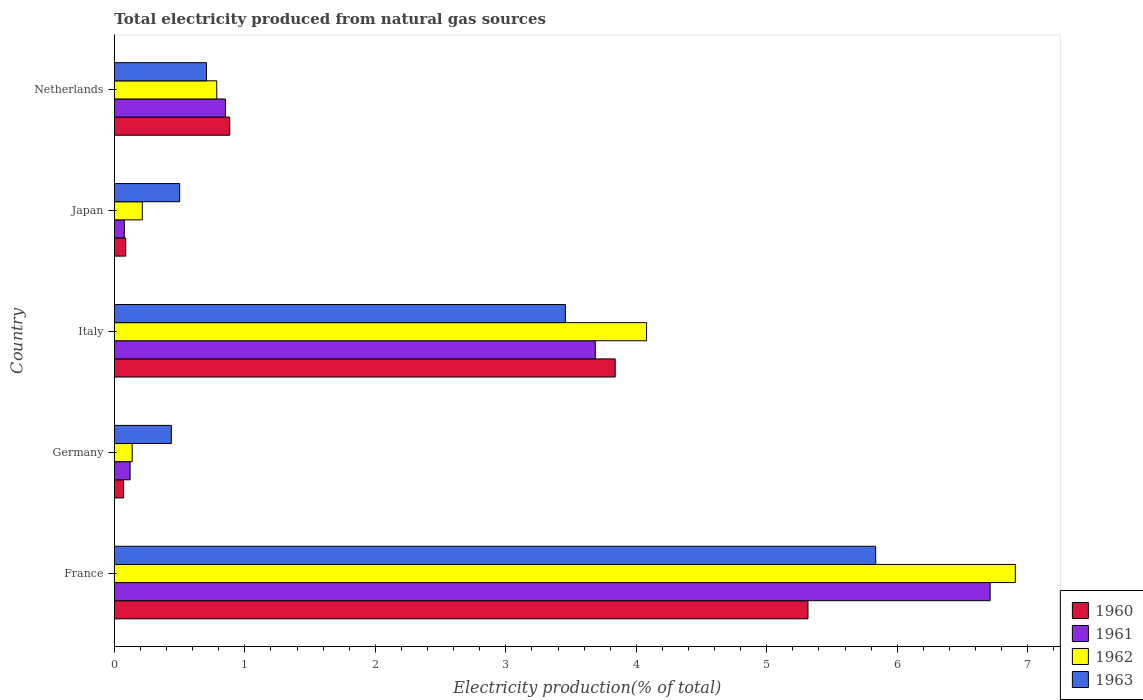Are the number of bars per tick equal to the number of legend labels?
Offer a terse response. Yes. Are the number of bars on each tick of the Y-axis equal?
Provide a short and direct response. Yes. What is the label of the 4th group of bars from the top?
Keep it short and to the point. Germany. What is the total electricity produced in 1963 in Italy?
Keep it short and to the point. 3.46. Across all countries, what is the maximum total electricity produced in 1960?
Offer a terse response. 5.32. Across all countries, what is the minimum total electricity produced in 1961?
Give a very brief answer. 0.08. In which country was the total electricity produced in 1961 maximum?
Make the answer very short. France. In which country was the total electricity produced in 1963 minimum?
Keep it short and to the point. Germany. What is the total total electricity produced in 1962 in the graph?
Your answer should be very brief. 12.12. What is the difference between the total electricity produced in 1963 in France and that in Netherlands?
Provide a succinct answer. 5.13. What is the difference between the total electricity produced in 1960 in Germany and the total electricity produced in 1963 in Netherlands?
Your answer should be compact. -0.64. What is the average total electricity produced in 1963 per country?
Keep it short and to the point. 2.19. What is the difference between the total electricity produced in 1963 and total electricity produced in 1961 in France?
Offer a very short reply. -0.88. What is the ratio of the total electricity produced in 1962 in Italy to that in Japan?
Offer a terse response. 19.09. Is the difference between the total electricity produced in 1963 in Germany and Netherlands greater than the difference between the total electricity produced in 1961 in Germany and Netherlands?
Your response must be concise. Yes. What is the difference between the highest and the second highest total electricity produced in 1960?
Make the answer very short. 1.48. What is the difference between the highest and the lowest total electricity produced in 1962?
Provide a short and direct response. 6.77. Is the sum of the total electricity produced in 1961 in Japan and Netherlands greater than the maximum total electricity produced in 1962 across all countries?
Ensure brevity in your answer.  No. What does the 2nd bar from the top in Netherlands represents?
Provide a short and direct response. 1962. Is it the case that in every country, the sum of the total electricity produced in 1960 and total electricity produced in 1963 is greater than the total electricity produced in 1961?
Ensure brevity in your answer.  Yes. How many bars are there?
Your response must be concise. 20. Are all the bars in the graph horizontal?
Provide a succinct answer. Yes. What is the difference between two consecutive major ticks on the X-axis?
Offer a terse response. 1. Where does the legend appear in the graph?
Provide a short and direct response. Bottom right. How are the legend labels stacked?
Provide a succinct answer. Vertical. What is the title of the graph?
Provide a short and direct response. Total electricity produced from natural gas sources. Does "1978" appear as one of the legend labels in the graph?
Provide a succinct answer. No. What is the label or title of the X-axis?
Keep it short and to the point. Electricity production(% of total). What is the label or title of the Y-axis?
Provide a short and direct response. Country. What is the Electricity production(% of total) in 1960 in France?
Your response must be concise. 5.32. What is the Electricity production(% of total) in 1961 in France?
Make the answer very short. 6.71. What is the Electricity production(% of total) of 1962 in France?
Provide a succinct answer. 6.91. What is the Electricity production(% of total) of 1963 in France?
Ensure brevity in your answer.  5.83. What is the Electricity production(% of total) in 1960 in Germany?
Offer a terse response. 0.07. What is the Electricity production(% of total) in 1961 in Germany?
Provide a short and direct response. 0.12. What is the Electricity production(% of total) in 1962 in Germany?
Your answer should be very brief. 0.14. What is the Electricity production(% of total) in 1963 in Germany?
Give a very brief answer. 0.44. What is the Electricity production(% of total) in 1960 in Italy?
Your answer should be compact. 3.84. What is the Electricity production(% of total) of 1961 in Italy?
Your answer should be compact. 3.69. What is the Electricity production(% of total) in 1962 in Italy?
Make the answer very short. 4.08. What is the Electricity production(% of total) of 1963 in Italy?
Ensure brevity in your answer.  3.46. What is the Electricity production(% of total) of 1960 in Japan?
Offer a terse response. 0.09. What is the Electricity production(% of total) of 1961 in Japan?
Keep it short and to the point. 0.08. What is the Electricity production(% of total) in 1962 in Japan?
Ensure brevity in your answer.  0.21. What is the Electricity production(% of total) in 1963 in Japan?
Offer a terse response. 0.5. What is the Electricity production(% of total) of 1960 in Netherlands?
Provide a short and direct response. 0.88. What is the Electricity production(% of total) of 1961 in Netherlands?
Ensure brevity in your answer.  0.85. What is the Electricity production(% of total) in 1962 in Netherlands?
Offer a terse response. 0.78. What is the Electricity production(% of total) of 1963 in Netherlands?
Ensure brevity in your answer.  0.71. Across all countries, what is the maximum Electricity production(% of total) in 1960?
Ensure brevity in your answer.  5.32. Across all countries, what is the maximum Electricity production(% of total) in 1961?
Your answer should be compact. 6.71. Across all countries, what is the maximum Electricity production(% of total) in 1962?
Ensure brevity in your answer.  6.91. Across all countries, what is the maximum Electricity production(% of total) of 1963?
Your answer should be compact. 5.83. Across all countries, what is the minimum Electricity production(% of total) in 1960?
Make the answer very short. 0.07. Across all countries, what is the minimum Electricity production(% of total) of 1961?
Provide a succinct answer. 0.08. Across all countries, what is the minimum Electricity production(% of total) of 1962?
Provide a short and direct response. 0.14. Across all countries, what is the minimum Electricity production(% of total) of 1963?
Provide a short and direct response. 0.44. What is the total Electricity production(% of total) in 1960 in the graph?
Provide a succinct answer. 10.19. What is the total Electricity production(% of total) of 1961 in the graph?
Your response must be concise. 11.45. What is the total Electricity production(% of total) in 1962 in the graph?
Offer a terse response. 12.12. What is the total Electricity production(% of total) in 1963 in the graph?
Keep it short and to the point. 10.93. What is the difference between the Electricity production(% of total) in 1960 in France and that in Germany?
Your answer should be very brief. 5.25. What is the difference between the Electricity production(% of total) in 1961 in France and that in Germany?
Give a very brief answer. 6.59. What is the difference between the Electricity production(% of total) in 1962 in France and that in Germany?
Your response must be concise. 6.77. What is the difference between the Electricity production(% of total) in 1963 in France and that in Germany?
Ensure brevity in your answer.  5.4. What is the difference between the Electricity production(% of total) in 1960 in France and that in Italy?
Provide a short and direct response. 1.48. What is the difference between the Electricity production(% of total) of 1961 in France and that in Italy?
Provide a short and direct response. 3.03. What is the difference between the Electricity production(% of total) in 1962 in France and that in Italy?
Your answer should be compact. 2.83. What is the difference between the Electricity production(% of total) of 1963 in France and that in Italy?
Offer a very short reply. 2.38. What is the difference between the Electricity production(% of total) in 1960 in France and that in Japan?
Your response must be concise. 5.23. What is the difference between the Electricity production(% of total) of 1961 in France and that in Japan?
Provide a short and direct response. 6.64. What is the difference between the Electricity production(% of total) of 1962 in France and that in Japan?
Your answer should be compact. 6.69. What is the difference between the Electricity production(% of total) in 1963 in France and that in Japan?
Your answer should be compact. 5.33. What is the difference between the Electricity production(% of total) in 1960 in France and that in Netherlands?
Give a very brief answer. 4.43. What is the difference between the Electricity production(% of total) in 1961 in France and that in Netherlands?
Provide a short and direct response. 5.86. What is the difference between the Electricity production(% of total) in 1962 in France and that in Netherlands?
Provide a short and direct response. 6.12. What is the difference between the Electricity production(% of total) of 1963 in France and that in Netherlands?
Provide a succinct answer. 5.13. What is the difference between the Electricity production(% of total) in 1960 in Germany and that in Italy?
Offer a very short reply. -3.77. What is the difference between the Electricity production(% of total) in 1961 in Germany and that in Italy?
Make the answer very short. -3.57. What is the difference between the Electricity production(% of total) in 1962 in Germany and that in Italy?
Provide a short and direct response. -3.94. What is the difference between the Electricity production(% of total) of 1963 in Germany and that in Italy?
Your answer should be compact. -3.02. What is the difference between the Electricity production(% of total) of 1960 in Germany and that in Japan?
Your response must be concise. -0.02. What is the difference between the Electricity production(% of total) of 1961 in Germany and that in Japan?
Offer a very short reply. 0.04. What is the difference between the Electricity production(% of total) in 1962 in Germany and that in Japan?
Offer a terse response. -0.08. What is the difference between the Electricity production(% of total) in 1963 in Germany and that in Japan?
Provide a short and direct response. -0.06. What is the difference between the Electricity production(% of total) of 1960 in Germany and that in Netherlands?
Give a very brief answer. -0.81. What is the difference between the Electricity production(% of total) in 1961 in Germany and that in Netherlands?
Offer a very short reply. -0.73. What is the difference between the Electricity production(% of total) of 1962 in Germany and that in Netherlands?
Your response must be concise. -0.65. What is the difference between the Electricity production(% of total) of 1963 in Germany and that in Netherlands?
Provide a short and direct response. -0.27. What is the difference between the Electricity production(% of total) of 1960 in Italy and that in Japan?
Provide a short and direct response. 3.75. What is the difference between the Electricity production(% of total) in 1961 in Italy and that in Japan?
Make the answer very short. 3.61. What is the difference between the Electricity production(% of total) of 1962 in Italy and that in Japan?
Offer a very short reply. 3.86. What is the difference between the Electricity production(% of total) in 1963 in Italy and that in Japan?
Your response must be concise. 2.96. What is the difference between the Electricity production(% of total) of 1960 in Italy and that in Netherlands?
Your answer should be compact. 2.95. What is the difference between the Electricity production(% of total) of 1961 in Italy and that in Netherlands?
Give a very brief answer. 2.83. What is the difference between the Electricity production(% of total) in 1962 in Italy and that in Netherlands?
Provide a succinct answer. 3.29. What is the difference between the Electricity production(% of total) in 1963 in Italy and that in Netherlands?
Make the answer very short. 2.75. What is the difference between the Electricity production(% of total) in 1960 in Japan and that in Netherlands?
Keep it short and to the point. -0.8. What is the difference between the Electricity production(% of total) in 1961 in Japan and that in Netherlands?
Your answer should be very brief. -0.78. What is the difference between the Electricity production(% of total) in 1962 in Japan and that in Netherlands?
Keep it short and to the point. -0.57. What is the difference between the Electricity production(% of total) in 1963 in Japan and that in Netherlands?
Ensure brevity in your answer.  -0.21. What is the difference between the Electricity production(% of total) of 1960 in France and the Electricity production(% of total) of 1961 in Germany?
Provide a short and direct response. 5.2. What is the difference between the Electricity production(% of total) of 1960 in France and the Electricity production(% of total) of 1962 in Germany?
Provide a short and direct response. 5.18. What is the difference between the Electricity production(% of total) in 1960 in France and the Electricity production(% of total) in 1963 in Germany?
Your answer should be compact. 4.88. What is the difference between the Electricity production(% of total) in 1961 in France and the Electricity production(% of total) in 1962 in Germany?
Your answer should be compact. 6.58. What is the difference between the Electricity production(% of total) of 1961 in France and the Electricity production(% of total) of 1963 in Germany?
Provide a short and direct response. 6.28. What is the difference between the Electricity production(% of total) in 1962 in France and the Electricity production(% of total) in 1963 in Germany?
Give a very brief answer. 6.47. What is the difference between the Electricity production(% of total) of 1960 in France and the Electricity production(% of total) of 1961 in Italy?
Make the answer very short. 1.63. What is the difference between the Electricity production(% of total) of 1960 in France and the Electricity production(% of total) of 1962 in Italy?
Provide a succinct answer. 1.24. What is the difference between the Electricity production(% of total) of 1960 in France and the Electricity production(% of total) of 1963 in Italy?
Make the answer very short. 1.86. What is the difference between the Electricity production(% of total) in 1961 in France and the Electricity production(% of total) in 1962 in Italy?
Offer a very short reply. 2.63. What is the difference between the Electricity production(% of total) in 1961 in France and the Electricity production(% of total) in 1963 in Italy?
Make the answer very short. 3.26. What is the difference between the Electricity production(% of total) in 1962 in France and the Electricity production(% of total) in 1963 in Italy?
Offer a very short reply. 3.45. What is the difference between the Electricity production(% of total) of 1960 in France and the Electricity production(% of total) of 1961 in Japan?
Offer a very short reply. 5.24. What is the difference between the Electricity production(% of total) of 1960 in France and the Electricity production(% of total) of 1962 in Japan?
Ensure brevity in your answer.  5.1. What is the difference between the Electricity production(% of total) in 1960 in France and the Electricity production(% of total) in 1963 in Japan?
Offer a terse response. 4.82. What is the difference between the Electricity production(% of total) of 1961 in France and the Electricity production(% of total) of 1962 in Japan?
Provide a succinct answer. 6.5. What is the difference between the Electricity production(% of total) in 1961 in France and the Electricity production(% of total) in 1963 in Japan?
Provide a succinct answer. 6.21. What is the difference between the Electricity production(% of total) of 1962 in France and the Electricity production(% of total) of 1963 in Japan?
Your response must be concise. 6.4. What is the difference between the Electricity production(% of total) in 1960 in France and the Electricity production(% of total) in 1961 in Netherlands?
Offer a very short reply. 4.46. What is the difference between the Electricity production(% of total) in 1960 in France and the Electricity production(% of total) in 1962 in Netherlands?
Your response must be concise. 4.53. What is the difference between the Electricity production(% of total) of 1960 in France and the Electricity production(% of total) of 1963 in Netherlands?
Keep it short and to the point. 4.61. What is the difference between the Electricity production(% of total) of 1961 in France and the Electricity production(% of total) of 1962 in Netherlands?
Give a very brief answer. 5.93. What is the difference between the Electricity production(% of total) of 1961 in France and the Electricity production(% of total) of 1963 in Netherlands?
Make the answer very short. 6.01. What is the difference between the Electricity production(% of total) in 1962 in France and the Electricity production(% of total) in 1963 in Netherlands?
Your response must be concise. 6.2. What is the difference between the Electricity production(% of total) of 1960 in Germany and the Electricity production(% of total) of 1961 in Italy?
Provide a short and direct response. -3.62. What is the difference between the Electricity production(% of total) of 1960 in Germany and the Electricity production(% of total) of 1962 in Italy?
Provide a short and direct response. -4.01. What is the difference between the Electricity production(% of total) of 1960 in Germany and the Electricity production(% of total) of 1963 in Italy?
Offer a very short reply. -3.39. What is the difference between the Electricity production(% of total) in 1961 in Germany and the Electricity production(% of total) in 1962 in Italy?
Your answer should be compact. -3.96. What is the difference between the Electricity production(% of total) in 1961 in Germany and the Electricity production(% of total) in 1963 in Italy?
Keep it short and to the point. -3.34. What is the difference between the Electricity production(% of total) in 1962 in Germany and the Electricity production(% of total) in 1963 in Italy?
Provide a succinct answer. -3.32. What is the difference between the Electricity production(% of total) of 1960 in Germany and the Electricity production(% of total) of 1961 in Japan?
Provide a short and direct response. -0.01. What is the difference between the Electricity production(% of total) of 1960 in Germany and the Electricity production(% of total) of 1962 in Japan?
Offer a very short reply. -0.14. What is the difference between the Electricity production(% of total) of 1960 in Germany and the Electricity production(% of total) of 1963 in Japan?
Your answer should be very brief. -0.43. What is the difference between the Electricity production(% of total) of 1961 in Germany and the Electricity production(% of total) of 1962 in Japan?
Your answer should be compact. -0.09. What is the difference between the Electricity production(% of total) in 1961 in Germany and the Electricity production(% of total) in 1963 in Japan?
Make the answer very short. -0.38. What is the difference between the Electricity production(% of total) of 1962 in Germany and the Electricity production(% of total) of 1963 in Japan?
Provide a succinct answer. -0.36. What is the difference between the Electricity production(% of total) of 1960 in Germany and the Electricity production(% of total) of 1961 in Netherlands?
Provide a short and direct response. -0.78. What is the difference between the Electricity production(% of total) of 1960 in Germany and the Electricity production(% of total) of 1962 in Netherlands?
Make the answer very short. -0.71. What is the difference between the Electricity production(% of total) in 1960 in Germany and the Electricity production(% of total) in 1963 in Netherlands?
Your answer should be compact. -0.64. What is the difference between the Electricity production(% of total) in 1961 in Germany and the Electricity production(% of total) in 1962 in Netherlands?
Your response must be concise. -0.66. What is the difference between the Electricity production(% of total) in 1961 in Germany and the Electricity production(% of total) in 1963 in Netherlands?
Ensure brevity in your answer.  -0.58. What is the difference between the Electricity production(% of total) in 1962 in Germany and the Electricity production(% of total) in 1963 in Netherlands?
Your answer should be very brief. -0.57. What is the difference between the Electricity production(% of total) of 1960 in Italy and the Electricity production(% of total) of 1961 in Japan?
Ensure brevity in your answer.  3.76. What is the difference between the Electricity production(% of total) of 1960 in Italy and the Electricity production(% of total) of 1962 in Japan?
Your answer should be very brief. 3.62. What is the difference between the Electricity production(% of total) in 1960 in Italy and the Electricity production(% of total) in 1963 in Japan?
Offer a very short reply. 3.34. What is the difference between the Electricity production(% of total) of 1961 in Italy and the Electricity production(% of total) of 1962 in Japan?
Make the answer very short. 3.47. What is the difference between the Electricity production(% of total) of 1961 in Italy and the Electricity production(% of total) of 1963 in Japan?
Your answer should be compact. 3.19. What is the difference between the Electricity production(% of total) in 1962 in Italy and the Electricity production(% of total) in 1963 in Japan?
Provide a short and direct response. 3.58. What is the difference between the Electricity production(% of total) in 1960 in Italy and the Electricity production(% of total) in 1961 in Netherlands?
Provide a succinct answer. 2.99. What is the difference between the Electricity production(% of total) in 1960 in Italy and the Electricity production(% of total) in 1962 in Netherlands?
Your answer should be very brief. 3.05. What is the difference between the Electricity production(% of total) in 1960 in Italy and the Electricity production(% of total) in 1963 in Netherlands?
Give a very brief answer. 3.13. What is the difference between the Electricity production(% of total) in 1961 in Italy and the Electricity production(% of total) in 1962 in Netherlands?
Provide a succinct answer. 2.9. What is the difference between the Electricity production(% of total) of 1961 in Italy and the Electricity production(% of total) of 1963 in Netherlands?
Your response must be concise. 2.98. What is the difference between the Electricity production(% of total) of 1962 in Italy and the Electricity production(% of total) of 1963 in Netherlands?
Provide a short and direct response. 3.37. What is the difference between the Electricity production(% of total) in 1960 in Japan and the Electricity production(% of total) in 1961 in Netherlands?
Make the answer very short. -0.76. What is the difference between the Electricity production(% of total) in 1960 in Japan and the Electricity production(% of total) in 1962 in Netherlands?
Your response must be concise. -0.7. What is the difference between the Electricity production(% of total) in 1960 in Japan and the Electricity production(% of total) in 1963 in Netherlands?
Offer a very short reply. -0.62. What is the difference between the Electricity production(% of total) of 1961 in Japan and the Electricity production(% of total) of 1962 in Netherlands?
Your response must be concise. -0.71. What is the difference between the Electricity production(% of total) of 1961 in Japan and the Electricity production(% of total) of 1963 in Netherlands?
Provide a short and direct response. -0.63. What is the difference between the Electricity production(% of total) of 1962 in Japan and the Electricity production(% of total) of 1963 in Netherlands?
Your answer should be compact. -0.49. What is the average Electricity production(% of total) of 1960 per country?
Keep it short and to the point. 2.04. What is the average Electricity production(% of total) in 1961 per country?
Offer a terse response. 2.29. What is the average Electricity production(% of total) of 1962 per country?
Your answer should be very brief. 2.42. What is the average Electricity production(% of total) of 1963 per country?
Offer a terse response. 2.19. What is the difference between the Electricity production(% of total) in 1960 and Electricity production(% of total) in 1961 in France?
Offer a terse response. -1.4. What is the difference between the Electricity production(% of total) in 1960 and Electricity production(% of total) in 1962 in France?
Provide a succinct answer. -1.59. What is the difference between the Electricity production(% of total) of 1960 and Electricity production(% of total) of 1963 in France?
Provide a short and direct response. -0.52. What is the difference between the Electricity production(% of total) of 1961 and Electricity production(% of total) of 1962 in France?
Make the answer very short. -0.19. What is the difference between the Electricity production(% of total) in 1961 and Electricity production(% of total) in 1963 in France?
Your answer should be very brief. 0.88. What is the difference between the Electricity production(% of total) in 1962 and Electricity production(% of total) in 1963 in France?
Provide a short and direct response. 1.07. What is the difference between the Electricity production(% of total) in 1960 and Electricity production(% of total) in 1962 in Germany?
Provide a short and direct response. -0.07. What is the difference between the Electricity production(% of total) of 1960 and Electricity production(% of total) of 1963 in Germany?
Ensure brevity in your answer.  -0.37. What is the difference between the Electricity production(% of total) in 1961 and Electricity production(% of total) in 1962 in Germany?
Your response must be concise. -0.02. What is the difference between the Electricity production(% of total) in 1961 and Electricity production(% of total) in 1963 in Germany?
Keep it short and to the point. -0.32. What is the difference between the Electricity production(% of total) in 1962 and Electricity production(% of total) in 1963 in Germany?
Keep it short and to the point. -0.3. What is the difference between the Electricity production(% of total) of 1960 and Electricity production(% of total) of 1961 in Italy?
Keep it short and to the point. 0.15. What is the difference between the Electricity production(% of total) of 1960 and Electricity production(% of total) of 1962 in Italy?
Ensure brevity in your answer.  -0.24. What is the difference between the Electricity production(% of total) of 1960 and Electricity production(% of total) of 1963 in Italy?
Provide a succinct answer. 0.38. What is the difference between the Electricity production(% of total) in 1961 and Electricity production(% of total) in 1962 in Italy?
Your answer should be very brief. -0.39. What is the difference between the Electricity production(% of total) of 1961 and Electricity production(% of total) of 1963 in Italy?
Your response must be concise. 0.23. What is the difference between the Electricity production(% of total) of 1962 and Electricity production(% of total) of 1963 in Italy?
Offer a very short reply. 0.62. What is the difference between the Electricity production(% of total) in 1960 and Electricity production(% of total) in 1961 in Japan?
Your response must be concise. 0.01. What is the difference between the Electricity production(% of total) in 1960 and Electricity production(% of total) in 1962 in Japan?
Keep it short and to the point. -0.13. What is the difference between the Electricity production(% of total) in 1960 and Electricity production(% of total) in 1963 in Japan?
Give a very brief answer. -0.41. What is the difference between the Electricity production(% of total) of 1961 and Electricity production(% of total) of 1962 in Japan?
Offer a very short reply. -0.14. What is the difference between the Electricity production(% of total) in 1961 and Electricity production(% of total) in 1963 in Japan?
Make the answer very short. -0.42. What is the difference between the Electricity production(% of total) of 1962 and Electricity production(% of total) of 1963 in Japan?
Your answer should be compact. -0.29. What is the difference between the Electricity production(% of total) of 1960 and Electricity production(% of total) of 1961 in Netherlands?
Provide a short and direct response. 0.03. What is the difference between the Electricity production(% of total) of 1960 and Electricity production(% of total) of 1962 in Netherlands?
Offer a very short reply. 0.1. What is the difference between the Electricity production(% of total) in 1960 and Electricity production(% of total) in 1963 in Netherlands?
Your response must be concise. 0.18. What is the difference between the Electricity production(% of total) in 1961 and Electricity production(% of total) in 1962 in Netherlands?
Make the answer very short. 0.07. What is the difference between the Electricity production(% of total) in 1961 and Electricity production(% of total) in 1963 in Netherlands?
Give a very brief answer. 0.15. What is the difference between the Electricity production(% of total) in 1962 and Electricity production(% of total) in 1963 in Netherlands?
Give a very brief answer. 0.08. What is the ratio of the Electricity production(% of total) in 1960 in France to that in Germany?
Give a very brief answer. 75.62. What is the ratio of the Electricity production(% of total) in 1961 in France to that in Germany?
Make the answer very short. 55.79. What is the ratio of the Electricity production(% of total) of 1962 in France to that in Germany?
Make the answer very short. 50.69. What is the ratio of the Electricity production(% of total) in 1963 in France to that in Germany?
Provide a short and direct response. 13.38. What is the ratio of the Electricity production(% of total) in 1960 in France to that in Italy?
Give a very brief answer. 1.39. What is the ratio of the Electricity production(% of total) of 1961 in France to that in Italy?
Your answer should be compact. 1.82. What is the ratio of the Electricity production(% of total) of 1962 in France to that in Italy?
Offer a terse response. 1.69. What is the ratio of the Electricity production(% of total) of 1963 in France to that in Italy?
Offer a terse response. 1.69. What is the ratio of the Electricity production(% of total) of 1960 in France to that in Japan?
Provide a succinct answer. 61.4. What is the ratio of the Electricity production(% of total) in 1961 in France to that in Japan?
Provide a short and direct response. 88.67. What is the ratio of the Electricity production(% of total) in 1962 in France to that in Japan?
Provide a short and direct response. 32.32. What is the ratio of the Electricity production(% of total) in 1963 in France to that in Japan?
Give a very brief answer. 11.67. What is the ratio of the Electricity production(% of total) in 1960 in France to that in Netherlands?
Keep it short and to the point. 6.01. What is the ratio of the Electricity production(% of total) in 1961 in France to that in Netherlands?
Offer a very short reply. 7.89. What is the ratio of the Electricity production(% of total) of 1962 in France to that in Netherlands?
Provide a succinct answer. 8.8. What is the ratio of the Electricity production(% of total) of 1963 in France to that in Netherlands?
Make the answer very short. 8.27. What is the ratio of the Electricity production(% of total) in 1960 in Germany to that in Italy?
Give a very brief answer. 0.02. What is the ratio of the Electricity production(% of total) in 1961 in Germany to that in Italy?
Your answer should be compact. 0.03. What is the ratio of the Electricity production(% of total) of 1962 in Germany to that in Italy?
Your answer should be compact. 0.03. What is the ratio of the Electricity production(% of total) in 1963 in Germany to that in Italy?
Ensure brevity in your answer.  0.13. What is the ratio of the Electricity production(% of total) in 1960 in Germany to that in Japan?
Offer a terse response. 0.81. What is the ratio of the Electricity production(% of total) in 1961 in Germany to that in Japan?
Your answer should be compact. 1.59. What is the ratio of the Electricity production(% of total) in 1962 in Germany to that in Japan?
Your answer should be very brief. 0.64. What is the ratio of the Electricity production(% of total) of 1963 in Germany to that in Japan?
Offer a very short reply. 0.87. What is the ratio of the Electricity production(% of total) in 1960 in Germany to that in Netherlands?
Your answer should be compact. 0.08. What is the ratio of the Electricity production(% of total) in 1961 in Germany to that in Netherlands?
Ensure brevity in your answer.  0.14. What is the ratio of the Electricity production(% of total) of 1962 in Germany to that in Netherlands?
Make the answer very short. 0.17. What is the ratio of the Electricity production(% of total) of 1963 in Germany to that in Netherlands?
Your answer should be very brief. 0.62. What is the ratio of the Electricity production(% of total) in 1960 in Italy to that in Japan?
Your answer should be compact. 44.33. What is the ratio of the Electricity production(% of total) in 1961 in Italy to that in Japan?
Keep it short and to the point. 48.69. What is the ratio of the Electricity production(% of total) in 1962 in Italy to that in Japan?
Provide a succinct answer. 19.09. What is the ratio of the Electricity production(% of total) in 1963 in Italy to that in Japan?
Your answer should be compact. 6.91. What is the ratio of the Electricity production(% of total) of 1960 in Italy to that in Netherlands?
Provide a short and direct response. 4.34. What is the ratio of the Electricity production(% of total) of 1961 in Italy to that in Netherlands?
Your answer should be compact. 4.33. What is the ratio of the Electricity production(% of total) of 1962 in Italy to that in Netherlands?
Offer a very short reply. 5.2. What is the ratio of the Electricity production(% of total) of 1963 in Italy to that in Netherlands?
Ensure brevity in your answer.  4.9. What is the ratio of the Electricity production(% of total) of 1960 in Japan to that in Netherlands?
Provide a succinct answer. 0.1. What is the ratio of the Electricity production(% of total) of 1961 in Japan to that in Netherlands?
Ensure brevity in your answer.  0.09. What is the ratio of the Electricity production(% of total) in 1962 in Japan to that in Netherlands?
Offer a terse response. 0.27. What is the ratio of the Electricity production(% of total) of 1963 in Japan to that in Netherlands?
Make the answer very short. 0.71. What is the difference between the highest and the second highest Electricity production(% of total) in 1960?
Offer a terse response. 1.48. What is the difference between the highest and the second highest Electricity production(% of total) of 1961?
Keep it short and to the point. 3.03. What is the difference between the highest and the second highest Electricity production(% of total) of 1962?
Provide a short and direct response. 2.83. What is the difference between the highest and the second highest Electricity production(% of total) in 1963?
Your response must be concise. 2.38. What is the difference between the highest and the lowest Electricity production(% of total) in 1960?
Keep it short and to the point. 5.25. What is the difference between the highest and the lowest Electricity production(% of total) in 1961?
Make the answer very short. 6.64. What is the difference between the highest and the lowest Electricity production(% of total) of 1962?
Offer a terse response. 6.77. What is the difference between the highest and the lowest Electricity production(% of total) in 1963?
Offer a terse response. 5.4. 